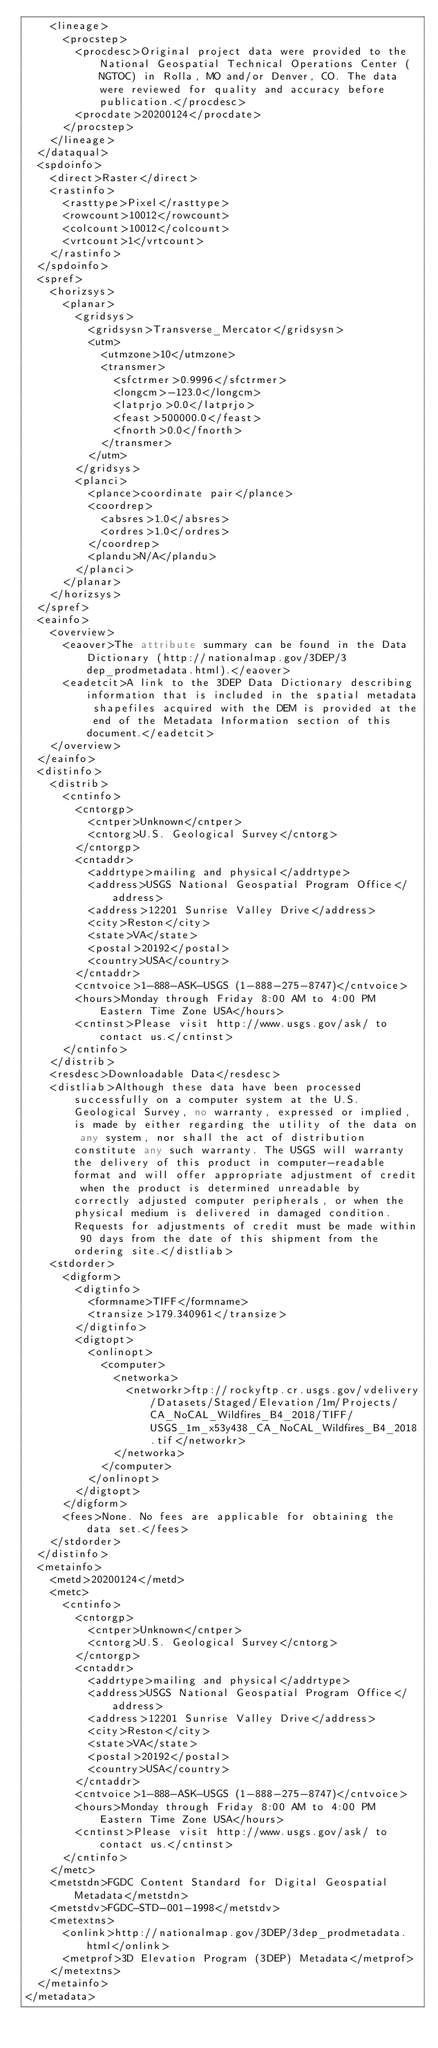Convert code to text. <code><loc_0><loc_0><loc_500><loc_500><_XML_>    <lineage>
      <procstep>
        <procdesc>Original project data were provided to the National Geospatial Technical Operations Center (NGTOC) in Rolla, MO and/or Denver, CO. The data were reviewed for quality and accuracy before publication.</procdesc>
        <procdate>20200124</procdate>
      </procstep>
    </lineage>
  </dataqual>
  <spdoinfo>
    <direct>Raster</direct>
    <rastinfo>
      <rasttype>Pixel</rasttype>
      <rowcount>10012</rowcount>
      <colcount>10012</colcount>
      <vrtcount>1</vrtcount>
    </rastinfo>
  </spdoinfo>
  <spref>
    <horizsys>
      <planar>
        <gridsys>
          <gridsysn>Transverse_Mercator</gridsysn>
          <utm>
            <utmzone>10</utmzone>
            <transmer>
              <sfctrmer>0.9996</sfctrmer>
              <longcm>-123.0</longcm>
              <latprjo>0.0</latprjo>
              <feast>500000.0</feast>
              <fnorth>0.0</fnorth>
            </transmer>
          </utm>
        </gridsys>
        <planci>
          <plance>coordinate pair</plance>
          <coordrep>
            <absres>1.0</absres>
            <ordres>1.0</ordres>
          </coordrep>
          <plandu>N/A</plandu>
        </planci>
      </planar>
    </horizsys>
  </spref>
  <eainfo>
    <overview>
      <eaover>The attribute summary can be found in the Data Dictionary (http://nationalmap.gov/3DEP/3dep_prodmetadata.html).</eaover>
      <eadetcit>A link to the 3DEP Data Dictionary describing information that is included in the spatial metadata shapefiles acquired with the DEM is provided at the end of the Metadata Information section of this document.</eadetcit>
    </overview>
  </eainfo>
  <distinfo>
    <distrib>
      <cntinfo>
        <cntorgp>
          <cntper>Unknown</cntper>
          <cntorg>U.S. Geological Survey</cntorg>
        </cntorgp>
        <cntaddr>
          <addrtype>mailing and physical</addrtype>
          <address>USGS National Geospatial Program Office</address>
          <address>12201 Sunrise Valley Drive</address>
          <city>Reston</city>
          <state>VA</state>
          <postal>20192</postal>
          <country>USA</country>
        </cntaddr>
        <cntvoice>1-888-ASK-USGS (1-888-275-8747)</cntvoice>
        <hours>Monday through Friday 8:00 AM to 4:00 PM Eastern Time Zone USA</hours>
        <cntinst>Please visit http://www.usgs.gov/ask/ to contact us.</cntinst>
      </cntinfo>
    </distrib>
    <resdesc>Downloadable Data</resdesc>
    <distliab>Although these data have been processed successfully on a computer system at the U.S. Geological Survey, no warranty, expressed or implied, is made by either regarding the utility of the data on any system, nor shall the act of distribution constitute any such warranty. The USGS will warranty the delivery of this product in computer-readable format and will offer appropriate adjustment of credit when the product is determined unreadable by correctly adjusted computer peripherals, or when the physical medium is delivered in damaged condition. Requests for adjustments of credit must be made within 90 days from the date of this shipment from the ordering site.</distliab>
    <stdorder>
      <digform>
        <digtinfo>
          <formname>TIFF</formname>
          <transize>179.340961</transize>
        </digtinfo>
        <digtopt>
          <onlinopt>
            <computer>
              <networka>
                <networkr>ftp://rockyftp.cr.usgs.gov/vdelivery/Datasets/Staged/Elevation/1m/Projects/CA_NoCAL_Wildfires_B4_2018/TIFF/USGS_1m_x53y438_CA_NoCAL_Wildfires_B4_2018.tif</networkr>
              </networka>
            </computer>
          </onlinopt>
        </digtopt>
      </digform>
      <fees>None. No fees are applicable for obtaining the data set.</fees>
    </stdorder>
  </distinfo>
  <metainfo>
    <metd>20200124</metd>
    <metc>
      <cntinfo>
        <cntorgp>
          <cntper>Unknown</cntper>
          <cntorg>U.S. Geological Survey</cntorg>
        </cntorgp>
        <cntaddr>
          <addrtype>mailing and physical</addrtype>
          <address>USGS National Geospatial Program Office</address>
          <address>12201 Sunrise Valley Drive</address>
          <city>Reston</city>
          <state>VA</state>
          <postal>20192</postal>
          <country>USA</country>
        </cntaddr>
        <cntvoice>1-888-ASK-USGS (1-888-275-8747)</cntvoice>
        <hours>Monday through Friday 8:00 AM to 4:00 PM Eastern Time Zone USA</hours>
        <cntinst>Please visit http://www.usgs.gov/ask/ to contact us.</cntinst>
      </cntinfo>
    </metc>
    <metstdn>FGDC Content Standard for Digital Geospatial Metadata</metstdn>
    <metstdv>FGDC-STD-001-1998</metstdv>
    <metextns>
      <onlink>http://nationalmap.gov/3DEP/3dep_prodmetadata.html</onlink>
      <metprof>3D Elevation Program (3DEP) Metadata</metprof>
    </metextns>
  </metainfo>
</metadata></code> 